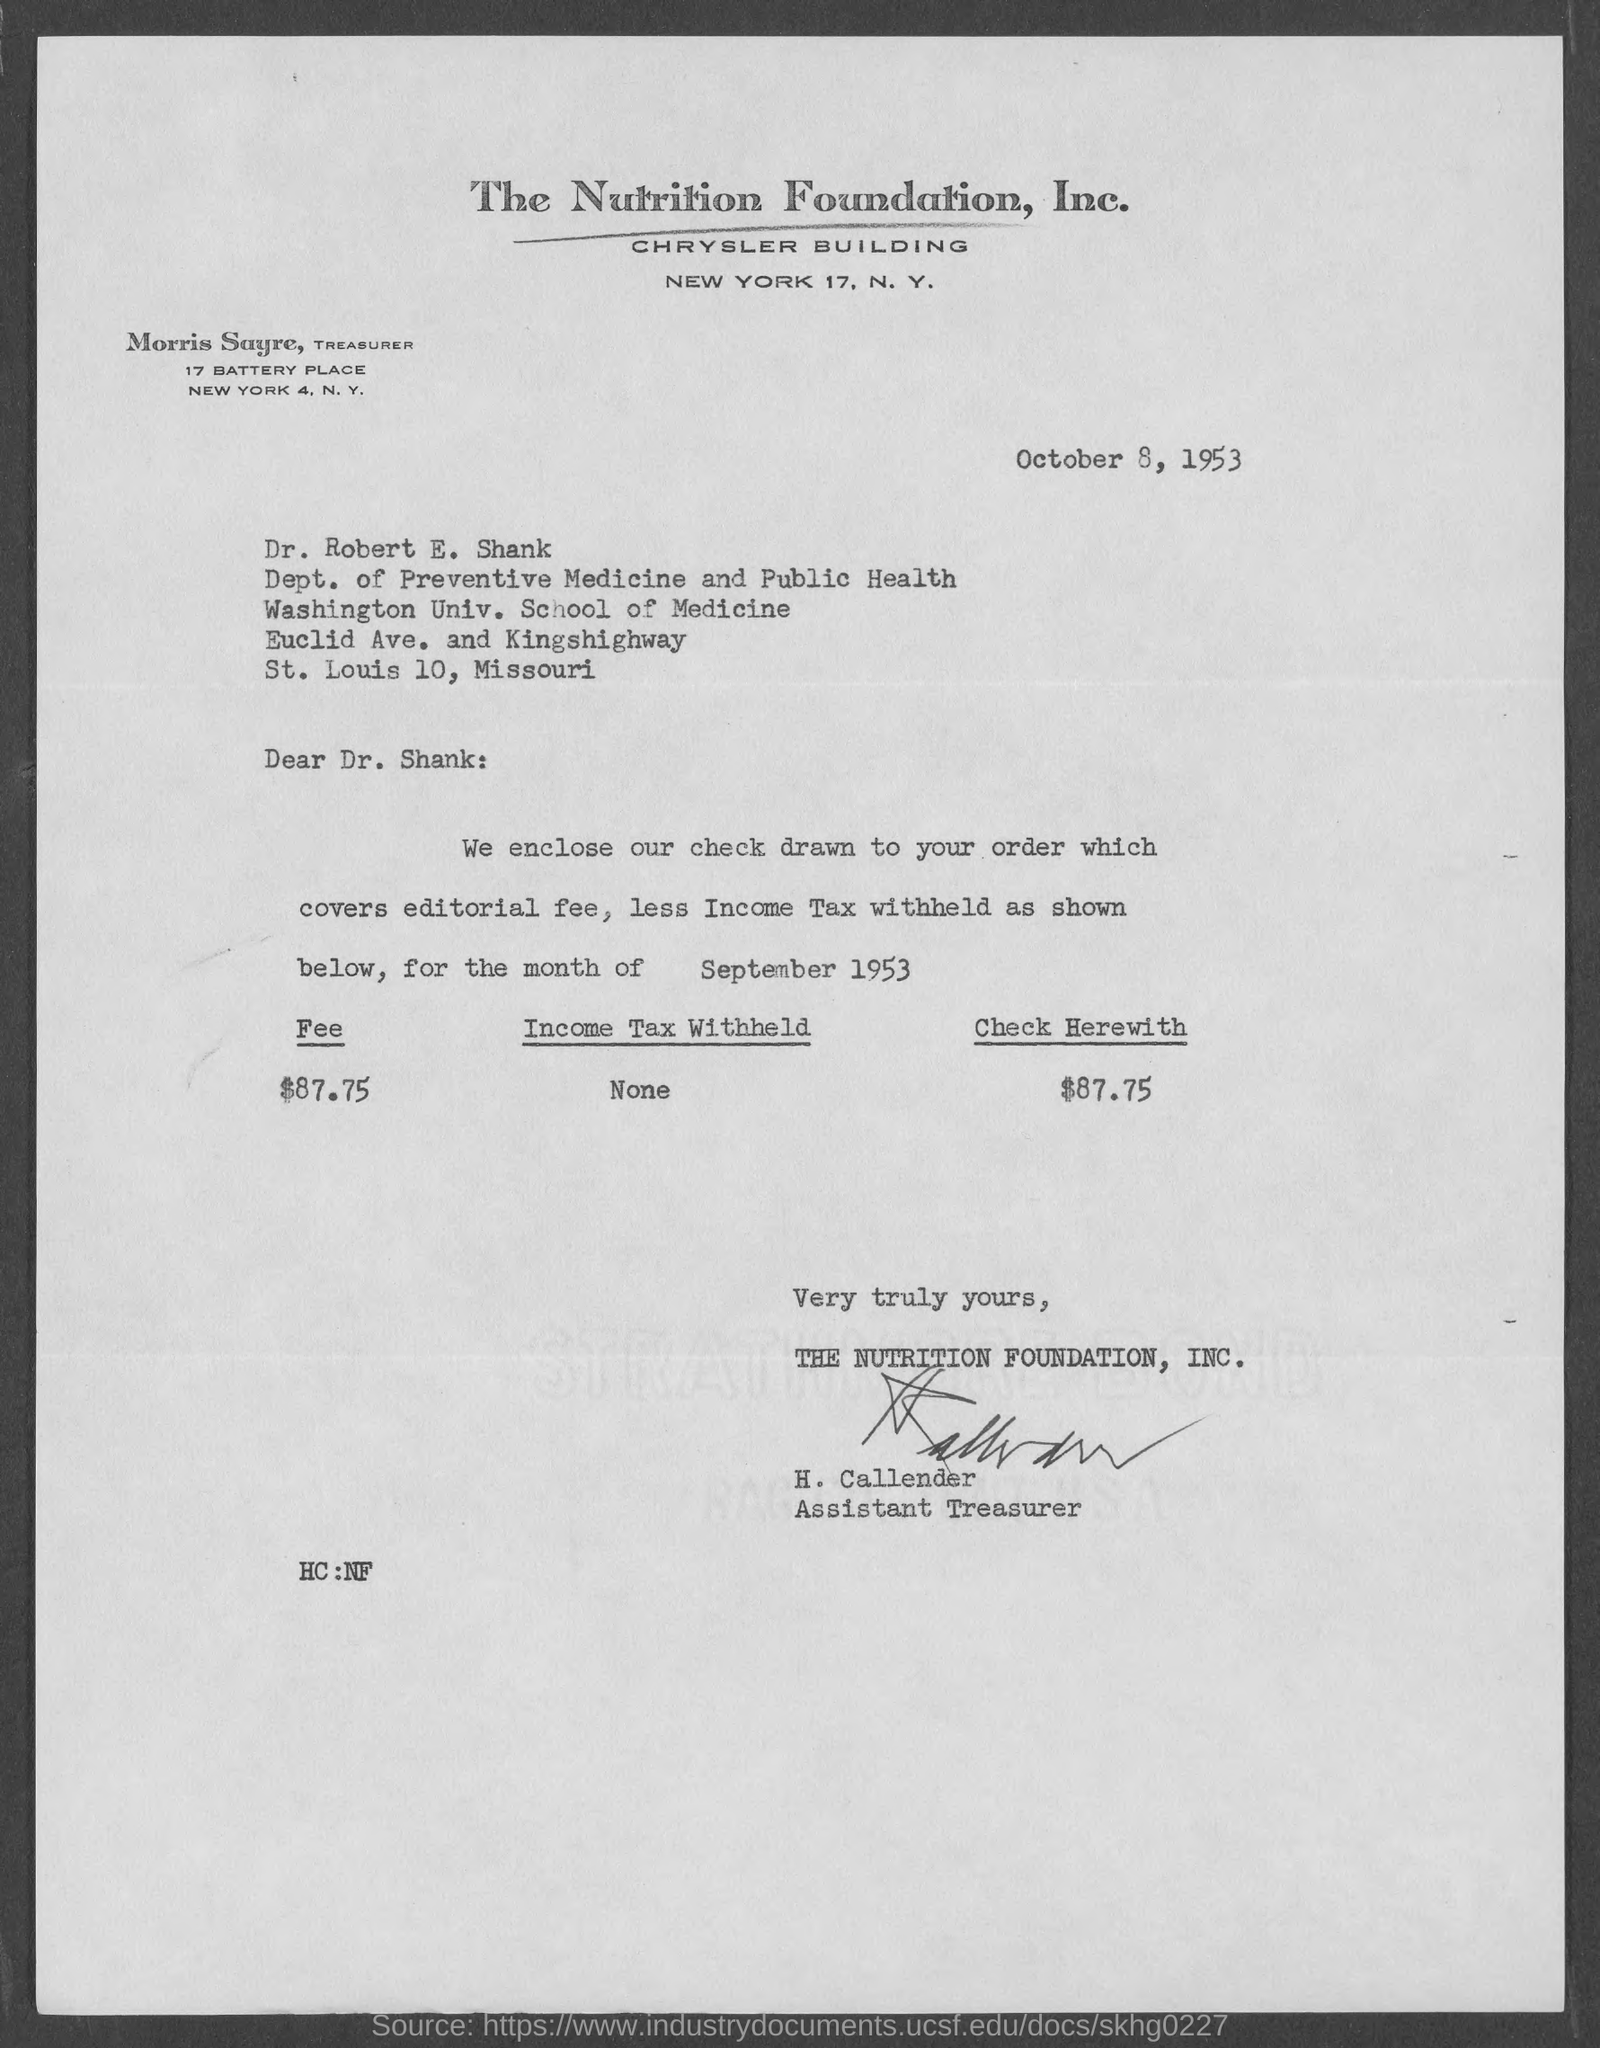Give some essential details in this illustration. The letter mentions an amount of $87.75 as the check. The letter mentions that no income tax withholding is present. The editorial fee, as per the letter, is $87.75. The date mentioned in this letter is October 8, 1953. The Nutrition Foundation, Inc. is the company that is mentioned in the letter head. 